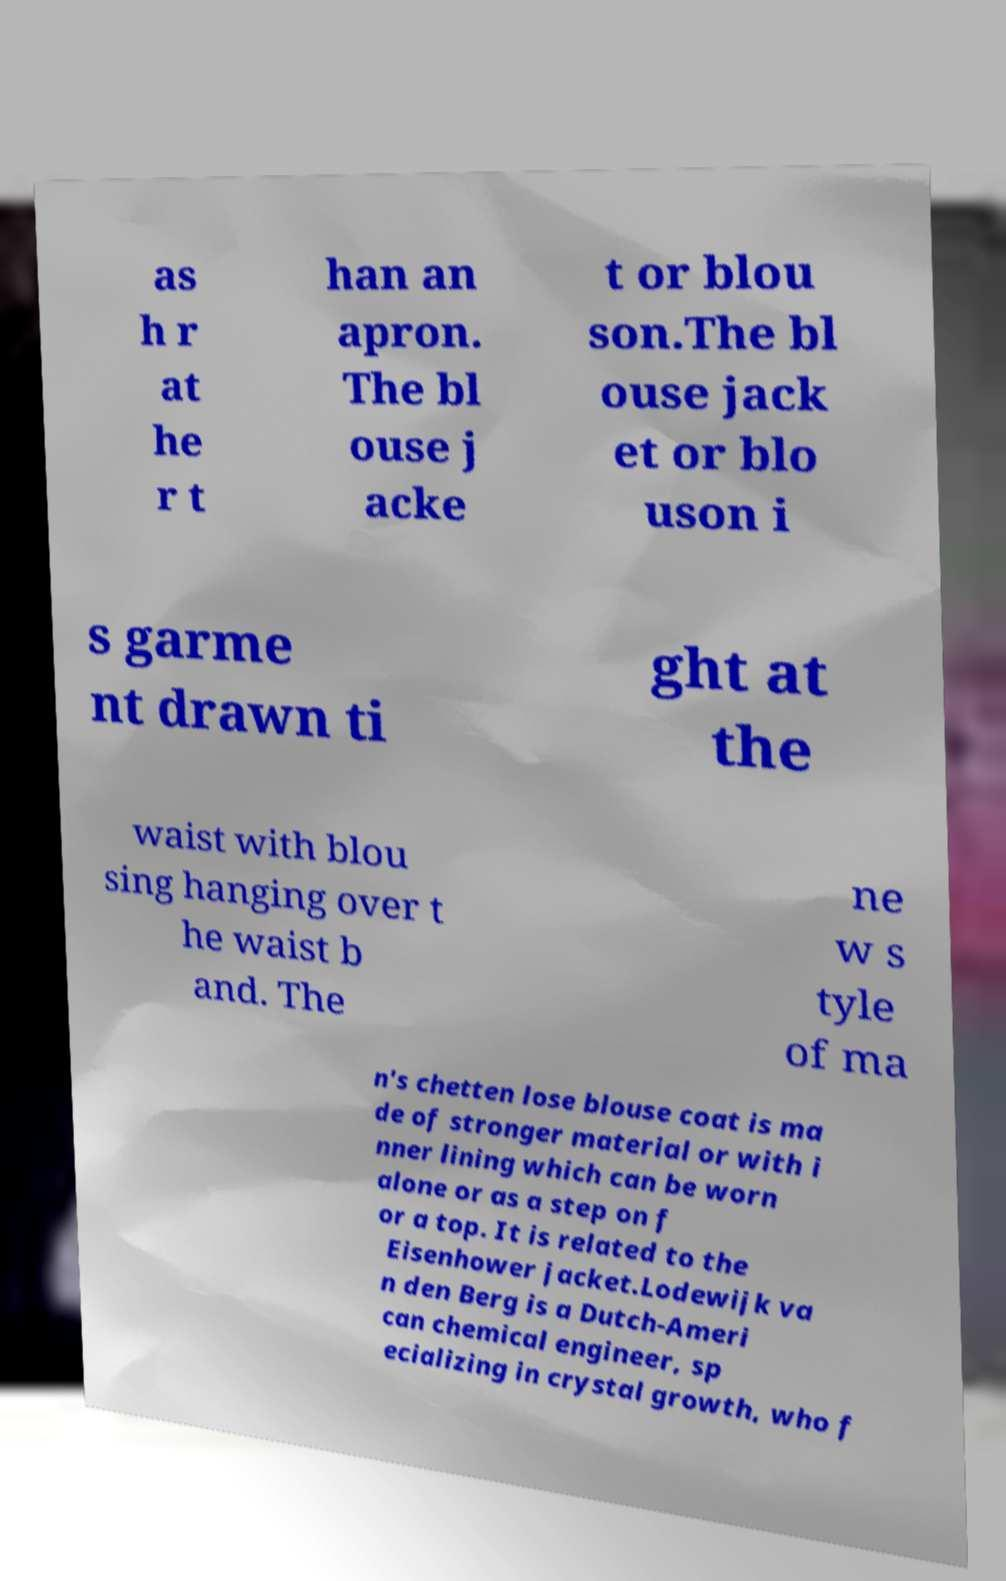What messages or text are displayed in this image? I need them in a readable, typed format. as h r at he r t han an apron. The bl ouse j acke t or blou son.The bl ouse jack et or blo uson i s garme nt drawn ti ght at the waist with blou sing hanging over t he waist b and. The ne w s tyle of ma n's chetten lose blouse coat is ma de of stronger material or with i nner lining which can be worn alone or as a step on f or a top. It is related to the Eisenhower jacket.Lodewijk va n den Berg is a Dutch-Ameri can chemical engineer, sp ecializing in crystal growth, who f 